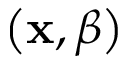<formula> <loc_0><loc_0><loc_500><loc_500>\left ( x , \beta \right )</formula> 